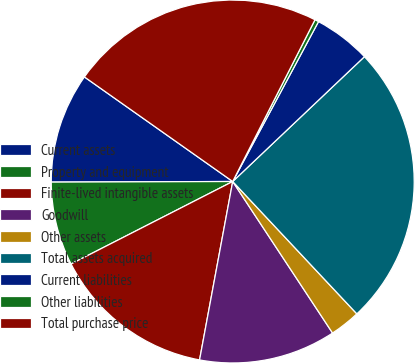Convert chart to OTSL. <chart><loc_0><loc_0><loc_500><loc_500><pie_chart><fcel>Current assets<fcel>Property and equipment<fcel>Finite-lived intangible assets<fcel>Goodwill<fcel>Other assets<fcel>Total assets acquired<fcel>Current liabilities<fcel>Other liabilities<fcel>Total purchase price<nl><fcel>9.83%<fcel>7.46%<fcel>14.57%<fcel>12.2%<fcel>2.72%<fcel>25.09%<fcel>5.09%<fcel>0.35%<fcel>22.72%<nl></chart> 